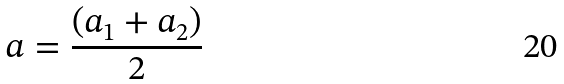Convert formula to latex. <formula><loc_0><loc_0><loc_500><loc_500>a = \frac { ( a _ { 1 } + a _ { 2 } ) } { 2 }</formula> 